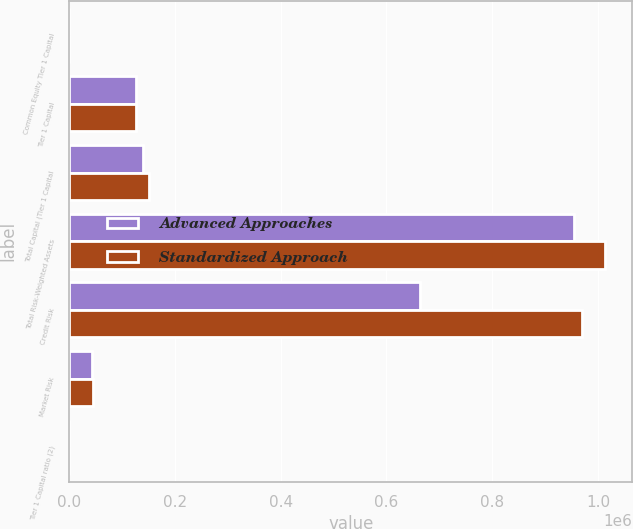<chart> <loc_0><loc_0><loc_500><loc_500><stacked_bar_chart><ecel><fcel>Common Equity Tier 1 Capital<fcel>Tier 1 Capital<fcel>Total Capital (Tier 1 Capital<fcel>Total Risk-Weighted Assets<fcel>Credit Risk<fcel>Market Risk<fcel>Tier 1 Capital ratio (2)<nl><fcel>Advanced Approaches<fcel>13.07<fcel>126303<fcel>139351<fcel>954559<fcel>663783<fcel>43300<fcel>13.23<nl><fcel>Standardized Approach<fcel>12.3<fcel>126303<fcel>150289<fcel>1.01424e+06<fcel>970064<fcel>44178<fcel>12.45<nl></chart> 